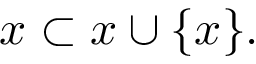<formula> <loc_0><loc_0><loc_500><loc_500>x \subset x \cup \{ x \} .</formula> 